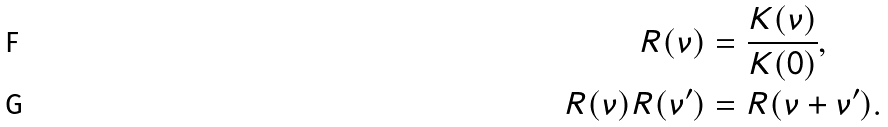<formula> <loc_0><loc_0><loc_500><loc_500>R ( \nu ) & = \frac { K ( \nu ) } { K ( 0 ) } , \\ R ( \nu ) R ( \nu ^ { \prime } ) & = R ( \nu + \nu ^ { \prime } ) .</formula> 